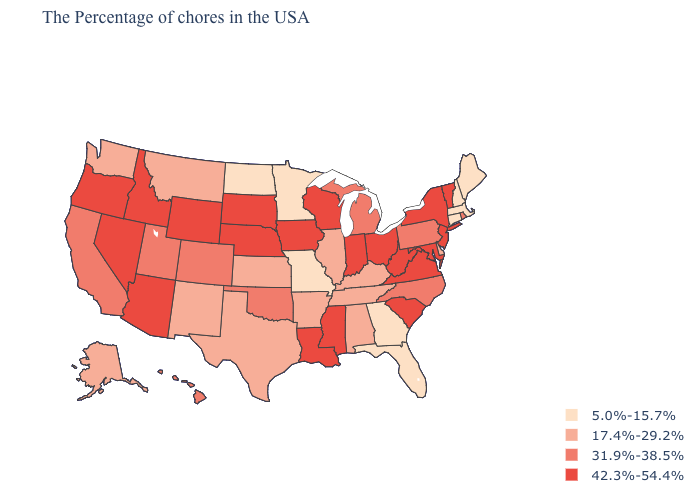What is the lowest value in states that border Minnesota?
Concise answer only. 5.0%-15.7%. Which states have the highest value in the USA?
Answer briefly. Vermont, New York, New Jersey, Maryland, Virginia, South Carolina, West Virginia, Ohio, Indiana, Wisconsin, Mississippi, Louisiana, Iowa, Nebraska, South Dakota, Wyoming, Arizona, Idaho, Nevada, Oregon. What is the value of Louisiana?
Quick response, please. 42.3%-54.4%. Name the states that have a value in the range 31.9%-38.5%?
Concise answer only. Rhode Island, Pennsylvania, North Carolina, Michigan, Oklahoma, Colorado, Utah, California, Hawaii. What is the lowest value in the USA?
Give a very brief answer. 5.0%-15.7%. Does Virginia have the same value as South Carolina?
Keep it brief. Yes. Name the states that have a value in the range 31.9%-38.5%?
Concise answer only. Rhode Island, Pennsylvania, North Carolina, Michigan, Oklahoma, Colorado, Utah, California, Hawaii. Name the states that have a value in the range 42.3%-54.4%?
Be succinct. Vermont, New York, New Jersey, Maryland, Virginia, South Carolina, West Virginia, Ohio, Indiana, Wisconsin, Mississippi, Louisiana, Iowa, Nebraska, South Dakota, Wyoming, Arizona, Idaho, Nevada, Oregon. Name the states that have a value in the range 17.4%-29.2%?
Give a very brief answer. Delaware, Kentucky, Alabama, Tennessee, Illinois, Arkansas, Kansas, Texas, New Mexico, Montana, Washington, Alaska. Among the states that border Connecticut , which have the lowest value?
Short answer required. Massachusetts. Among the states that border New Hampshire , which have the highest value?
Concise answer only. Vermont. What is the highest value in the Northeast ?
Keep it brief. 42.3%-54.4%. Which states have the lowest value in the USA?
Answer briefly. Maine, Massachusetts, New Hampshire, Connecticut, Florida, Georgia, Missouri, Minnesota, North Dakota. Name the states that have a value in the range 17.4%-29.2%?
Write a very short answer. Delaware, Kentucky, Alabama, Tennessee, Illinois, Arkansas, Kansas, Texas, New Mexico, Montana, Washington, Alaska. Does the first symbol in the legend represent the smallest category?
Quick response, please. Yes. 